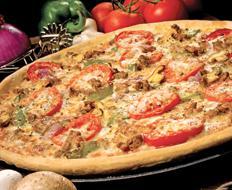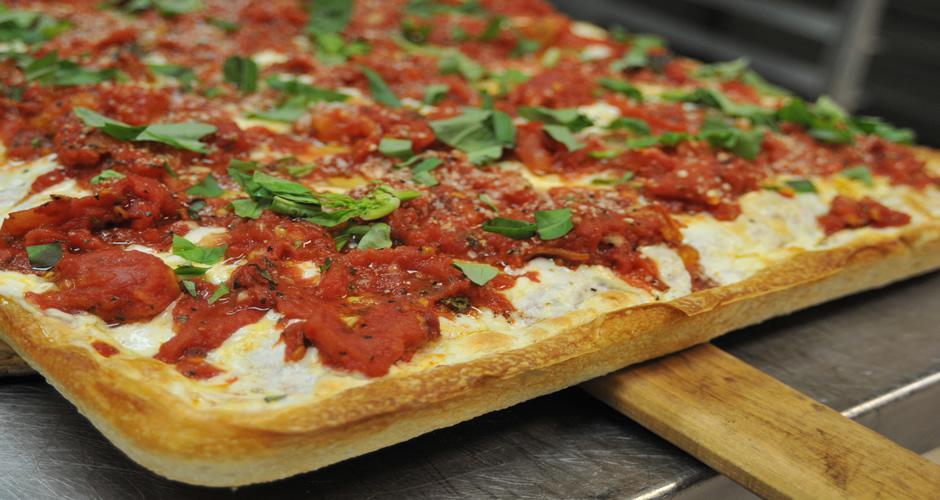The first image is the image on the left, the second image is the image on the right. Given the left and right images, does the statement "There are two round full pizzas." hold true? Answer yes or no. No. The first image is the image on the left, the second image is the image on the right. Assess this claim about the two images: "At least one of the pizzas has sliced olives on it.". Correct or not? Answer yes or no. No. 